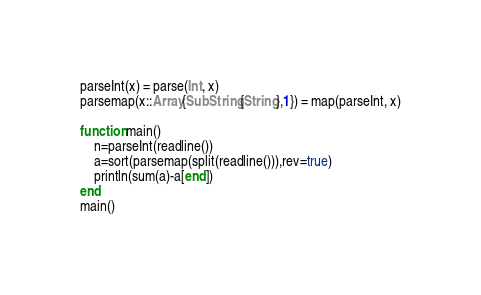Convert code to text. <code><loc_0><loc_0><loc_500><loc_500><_Julia_>parseInt(x) = parse(Int, x)
parsemap(x::Array{SubString{String},1}) = map(parseInt, x)

function main()
    n=parseInt(readline())
    a=sort(parsemap(split(readline())),rev=true)
    println(sum(a)-a[end])
end
main()</code> 